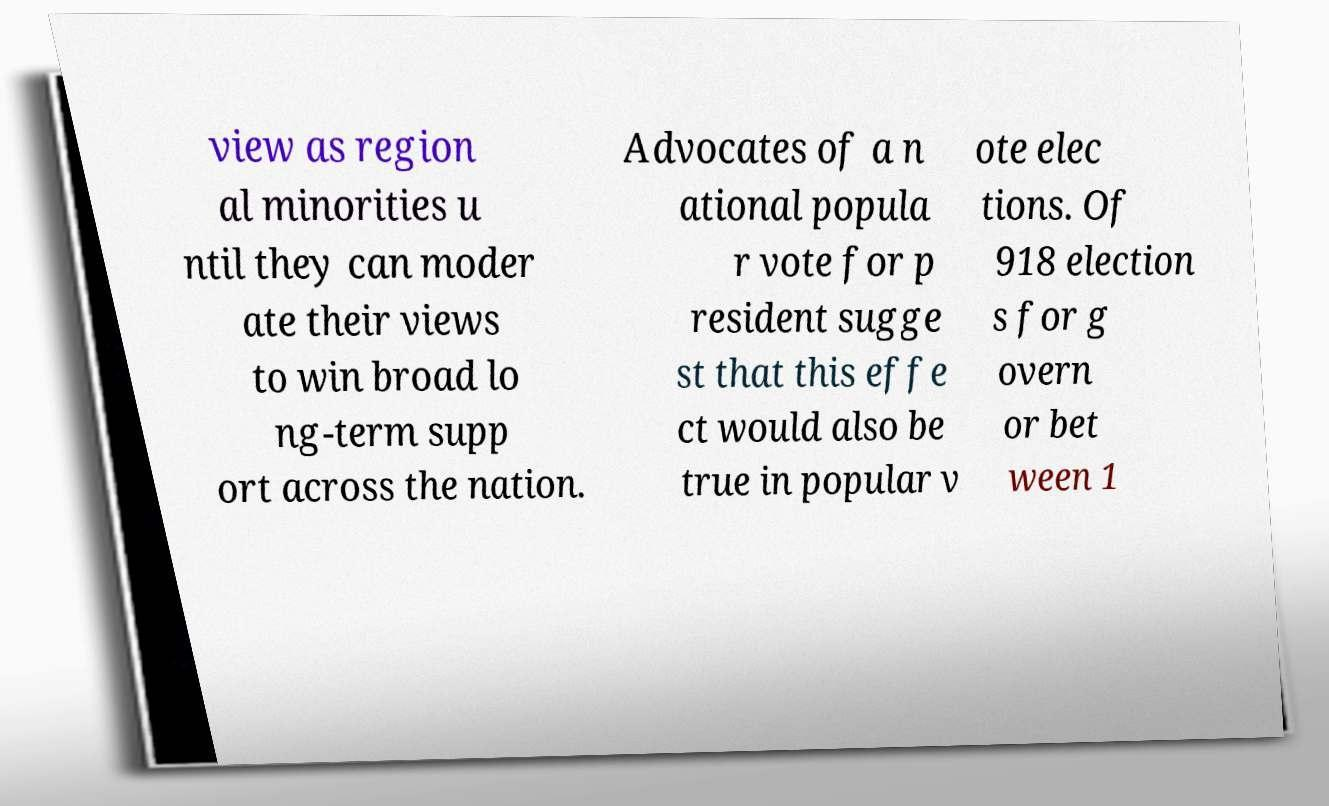Could you assist in decoding the text presented in this image and type it out clearly? view as region al minorities u ntil they can moder ate their views to win broad lo ng-term supp ort across the nation. Advocates of a n ational popula r vote for p resident sugge st that this effe ct would also be true in popular v ote elec tions. Of 918 election s for g overn or bet ween 1 